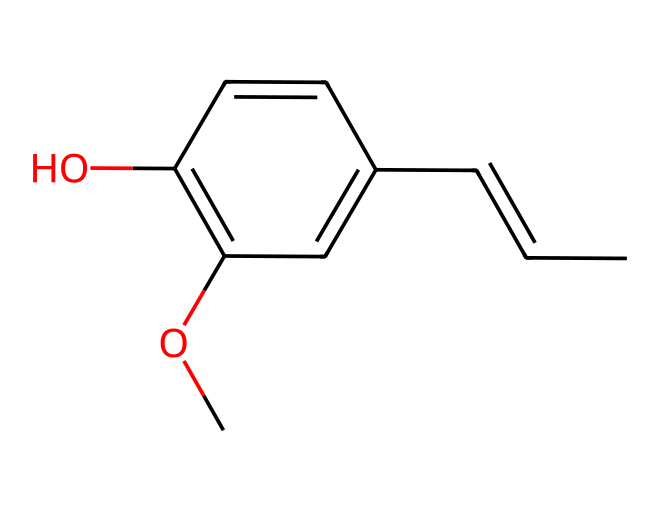What is the molecular formula of eugenol? To find the molecular formula, count the number of each type of atom in the chemical structure represented by the SMILES notation. In this case, there are 10 carbon atoms, 12 hydrogen atoms, and 2 oxygen atoms. Therefore, the molecular formula is C10H12O2.
Answer: C10H12O2 How many rings are present in eugenol? The SMILES representation indicates that there is one ring structure as seen in the part "C1" which starts the ring and finishes with "C1," confirming the presence of a single aromatic ring.
Answer: 1 What type of functional groups are present in eugenol? The structure includes a hydroxyl group (-OH) and an ether group (-O-), which characterize it as a phenolic compound. Thus, it contains both a phenol and ether functional group.
Answer: phenol and ether What type of chemical is eugenol classified as? Given that this compound contains a hydroxyl group attached to an aromatic ring, it is classified as a phenol. This classification can be directly inferred from the structure's functional groups.
Answer: phenol How many double bonds are present in the eugenol structure? From the SMILES notation, you can identify the presence of two double bonds in the carbon chain and within the aromatic ring, making it a total of two double bonds in the entire structure.
Answer: 2 What characteristic of phenols does eugenol exhibit due to its structure? Eugenol exhibits typical phenolic characteristics such as antiseptic or analgesic properties, which can be attributed to the hydroxyl group attached to the aromatic ring.
Answer: antiseptic and analgesic properties 